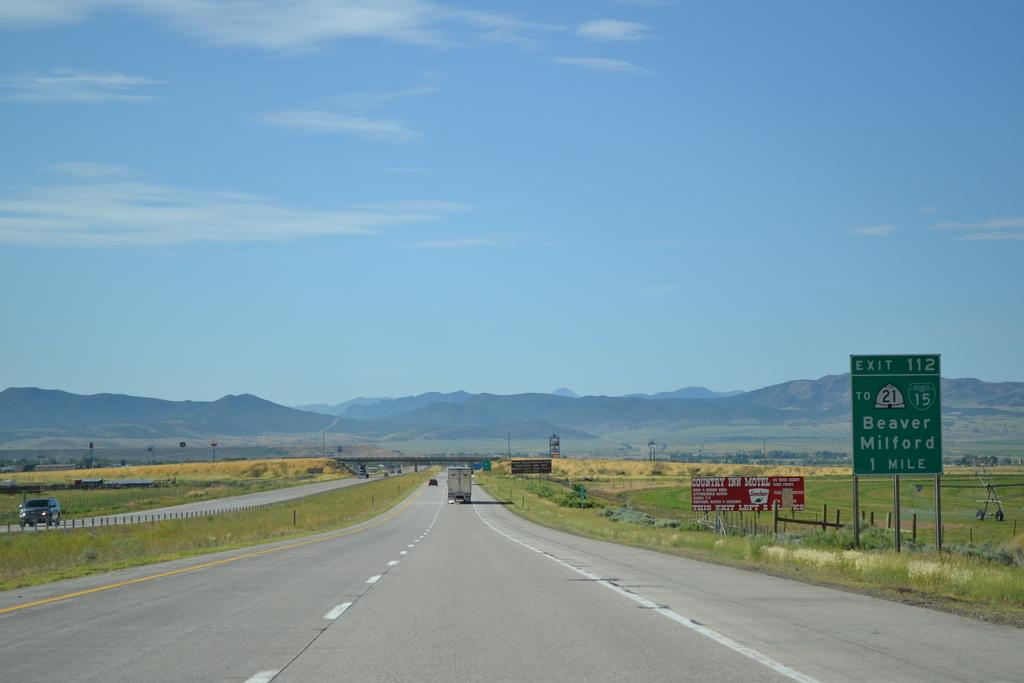What can be seen in the sky in the image? The sky with clouds is visible in the image. What type of natural feature is present in the image? There are hills in the image. What mode of transportation can be seen on the road? Motor vehicles are present on the road. What safety feature is visible in the image? Barrier poles are visible in the image. What type of signs are present in the image? Sign boards and information boards are present in the image. What type of land use is visible in the image? Agricultural farms are visible in the image. What type of vegetation is present in the image? Grass is present in the image. How many buns can be seen on the mountain in the image? There is no mountain or buns present in the image. 